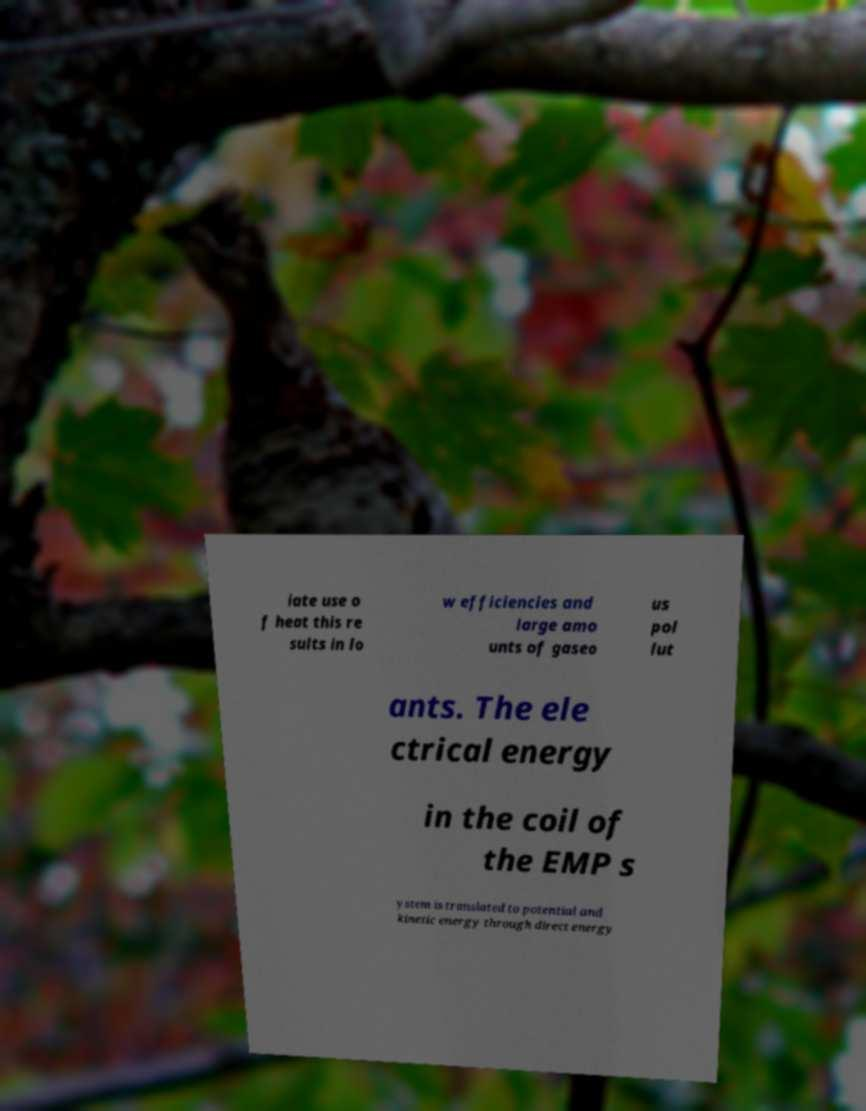There's text embedded in this image that I need extracted. Can you transcribe it verbatim? iate use o f heat this re sults in lo w efficiencies and large amo unts of gaseo us pol lut ants. The ele ctrical energy in the coil of the EMP s ystem is translated to potential and kinetic energy through direct energy 